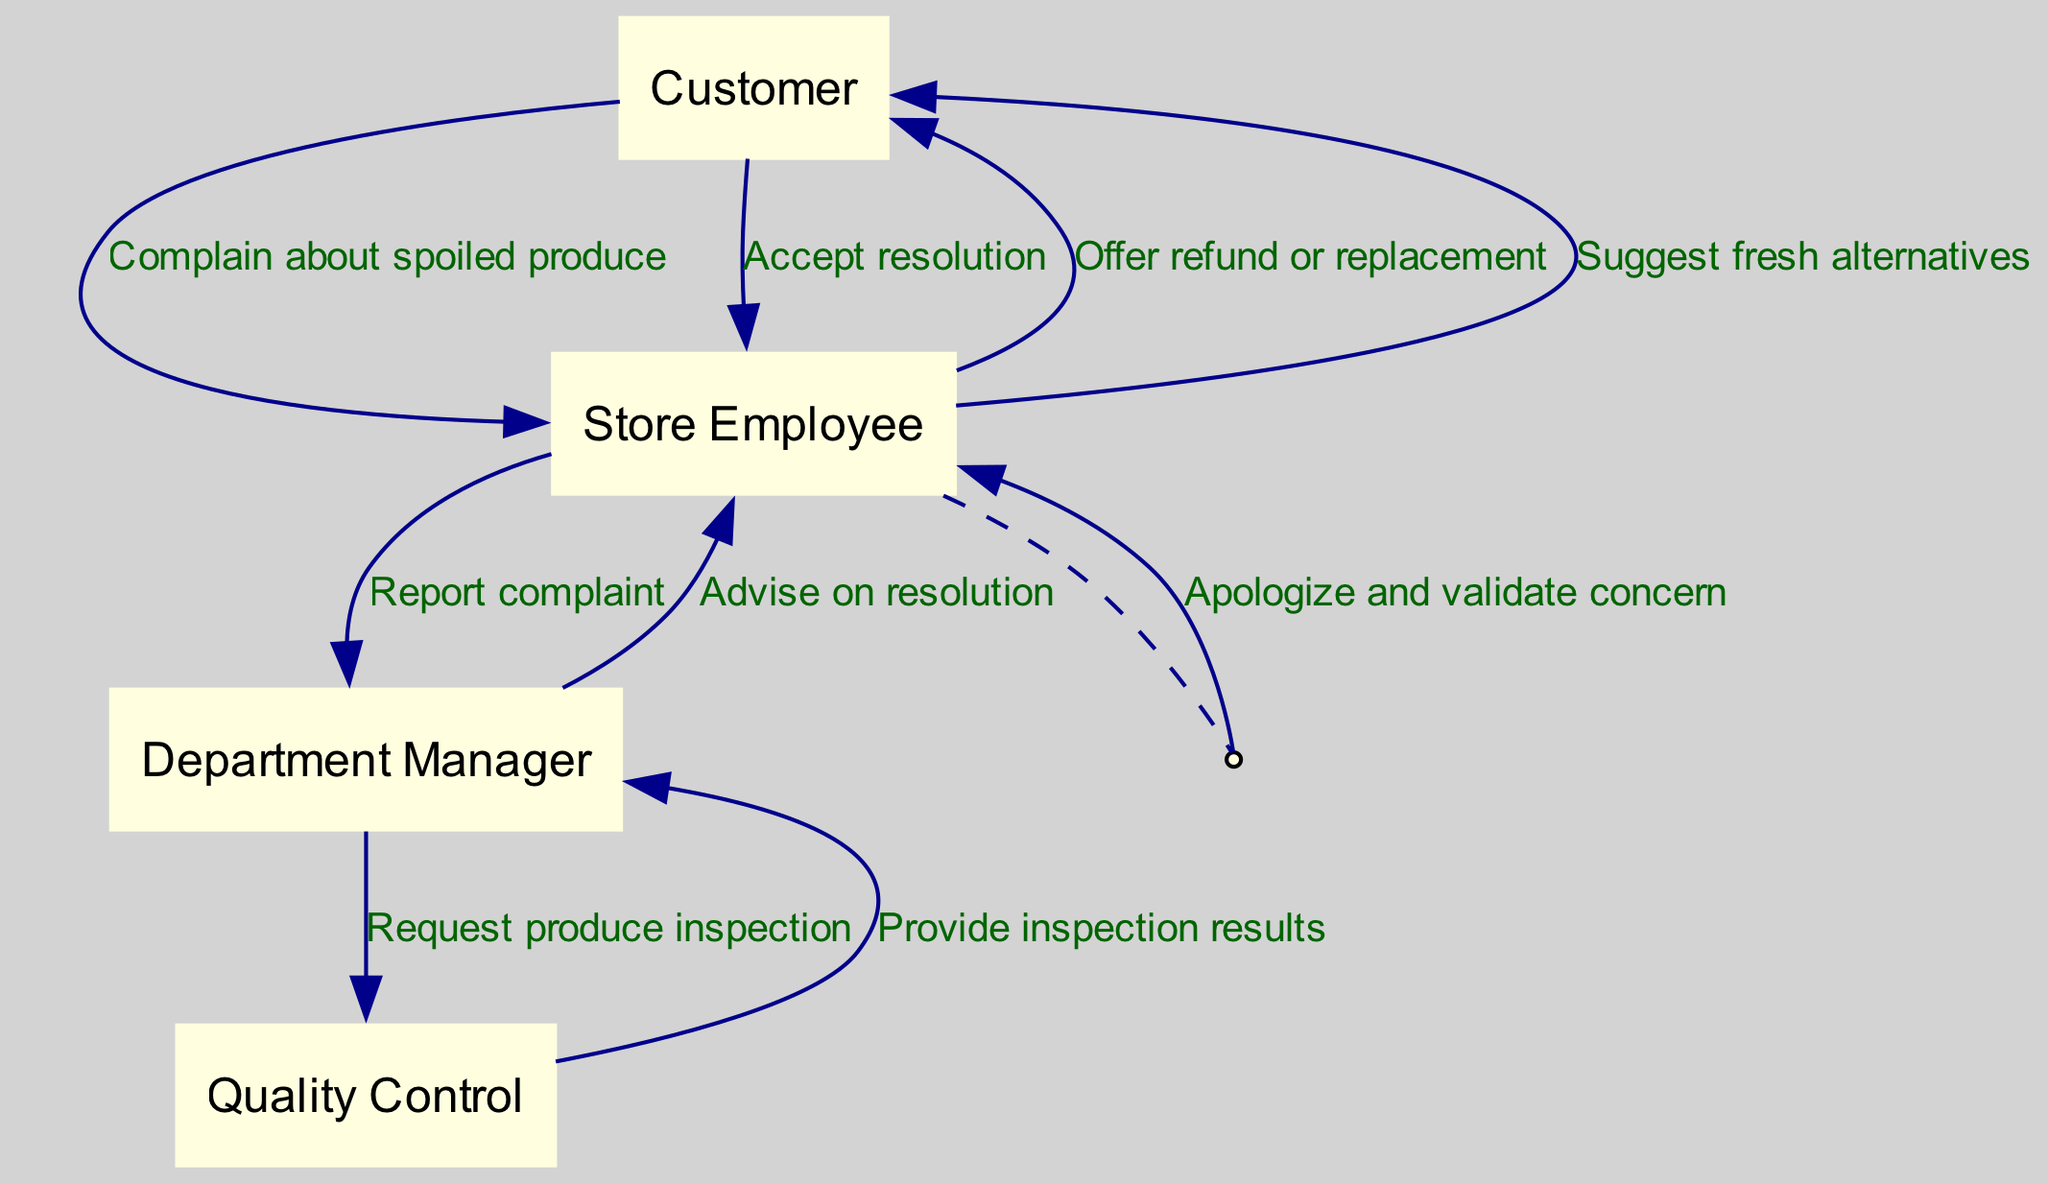What is the first action taken by the customer? The first action taken by the customer is to complain about spoiled produce. This is evident in the first message in the sequence diagram where the customer interacts with the store employee.
Answer: Complain about spoiled produce What role does the Department Manager play in the complaint resolution? The Department Manager receives a report of the complaint from the store employee and then requests a produce inspection from the Quality Control team. This indicates that the Department Manager acts as a mediator and takes further actions based on the complaint reported to them.
Answer: Request produce inspection How many interactions occur between the Store Employee and the Customer? The diagram shows two interactions between the Store Employee and the Customer after the initial complaint: one where the Store Employee offers a refund or replacement, and another where they suggest fresh alternatives. Thus, there are two distinct interactions illustrated.
Answer: Two What message does Quality Control send back to the Department Manager? Quality Control provides inspection results to the Department Manager. This is indicated as a key piece of information flowing from the Quality Control actor back to the Department Manager in the sequence of actions.
Answer: Provide inspection results Who validates the customer's concern after the complaint is made? The Store Employee validates the concern by apologizing to the customer after receiving the complaint about spoiled produce. This can be seen in the second action within the sequence that reflects the Store Employee's immediate response to the customer's issue.
Answer: Apologize and validate concern Which actor is responsible for advising on the resolution? The Department Manager is responsible for advising on the resolution once they receive the inspection results from Quality Control. This demonstrates their role in deciding the next steps for handling the complaint based on the information provided.
Answer: Advise on resolution What is the final action taken by the Customer in this sequence? The final action taken by the Customer in this sequence is to accept the resolution offered by the Store Employee. This indicates that the customer has agreed to the suggested alternatives or compensation provided after the complaint process.
Answer: Accept resolution 